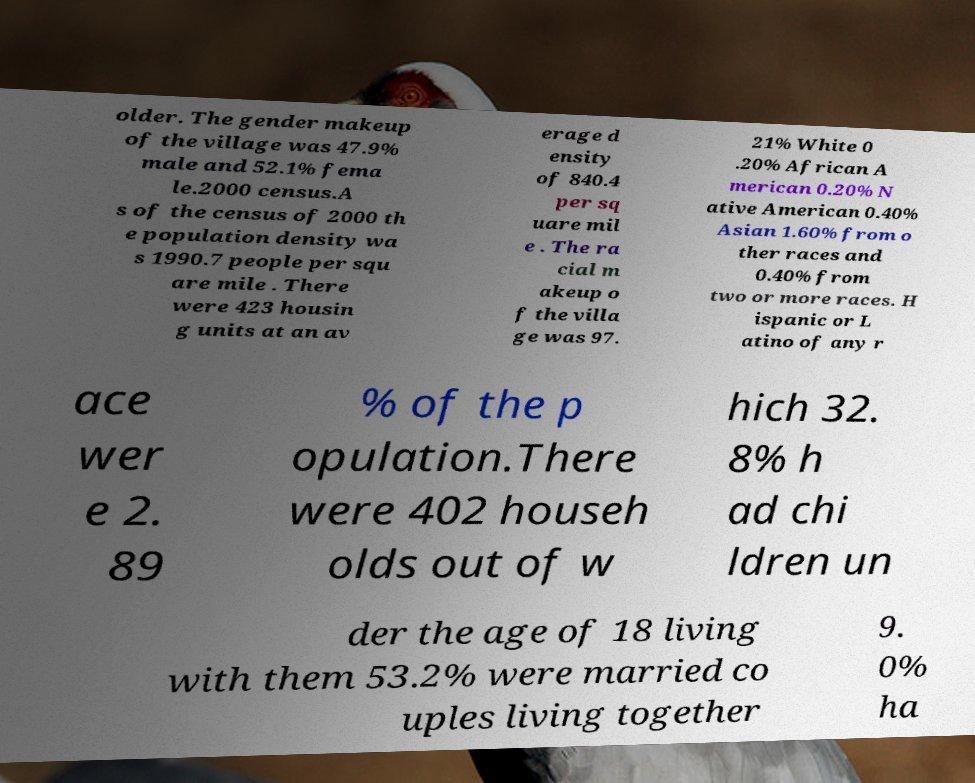Please identify and transcribe the text found in this image. older. The gender makeup of the village was 47.9% male and 52.1% fema le.2000 census.A s of the census of 2000 th e population density wa s 1990.7 people per squ are mile . There were 423 housin g units at an av erage d ensity of 840.4 per sq uare mil e . The ra cial m akeup o f the villa ge was 97. 21% White 0 .20% African A merican 0.20% N ative American 0.40% Asian 1.60% from o ther races and 0.40% from two or more races. H ispanic or L atino of any r ace wer e 2. 89 % of the p opulation.There were 402 househ olds out of w hich 32. 8% h ad chi ldren un der the age of 18 living with them 53.2% were married co uples living together 9. 0% ha 